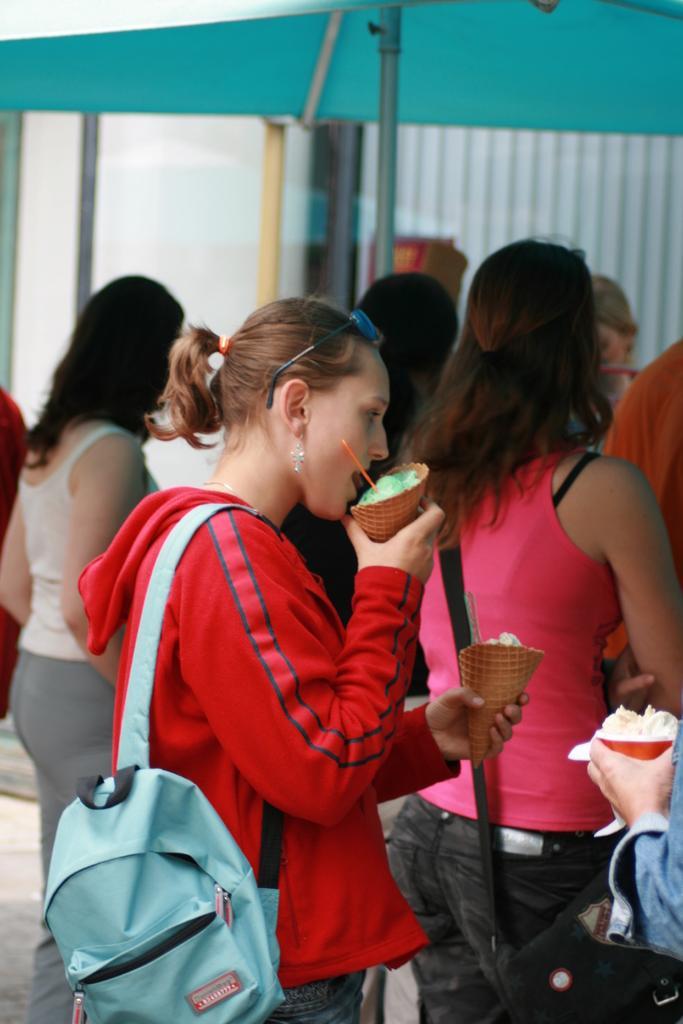In one or two sentences, can you explain what this image depicts? The women wearing red dress is holding ice creams in both of her hands and there are group of ladies beside her. 